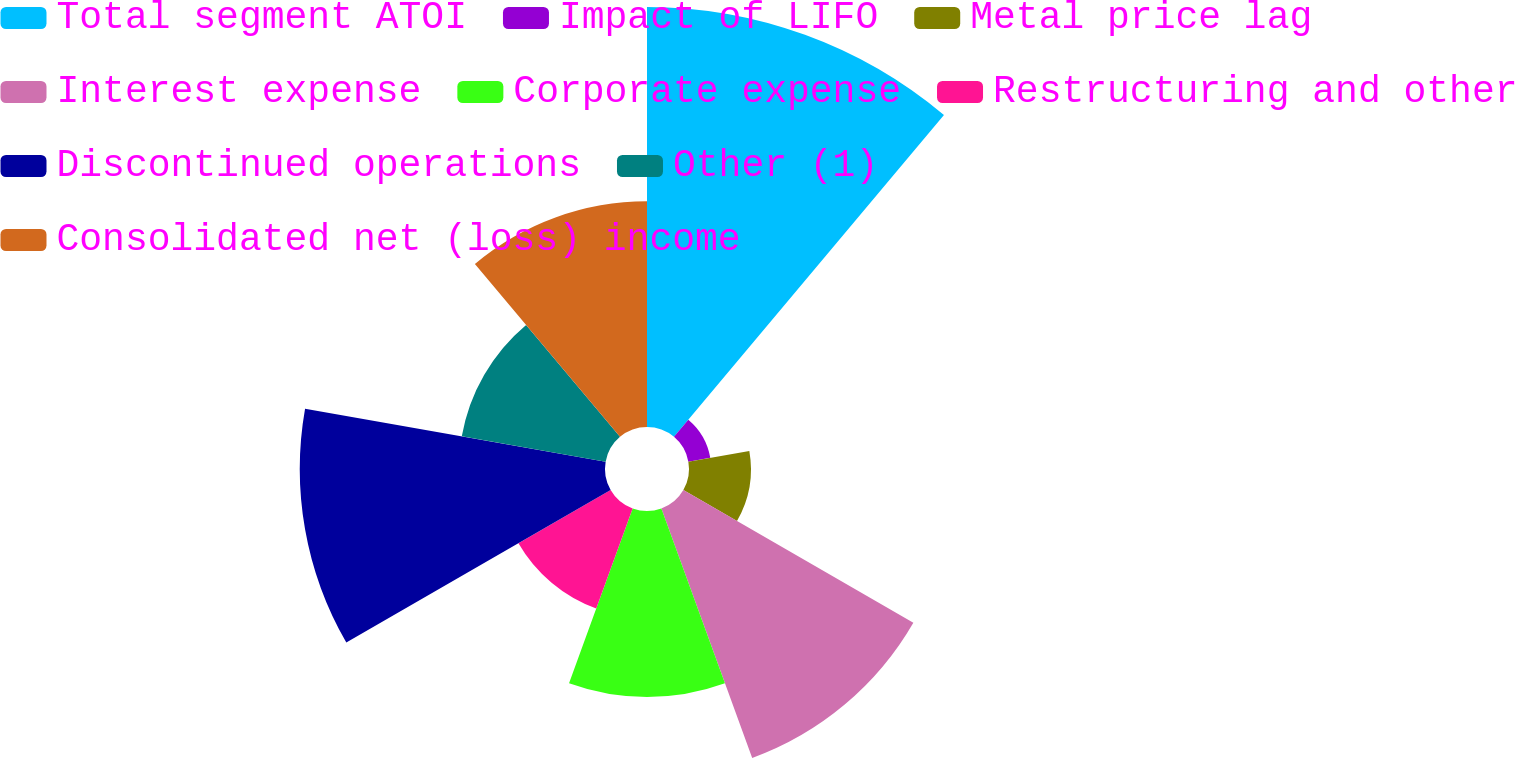<chart> <loc_0><loc_0><loc_500><loc_500><pie_chart><fcel>Total segment ATOI<fcel>Impact of LIFO<fcel>Metal price lag<fcel>Interest expense<fcel>Corporate expense<fcel>Restructuring and other<fcel>Discontinued operations<fcel>Other (1)<fcel>Consolidated net (loss) income<nl><fcel>24.15%<fcel>1.28%<fcel>3.56%<fcel>15.27%<fcel>10.69%<fcel>6.12%<fcel>17.55%<fcel>8.4%<fcel>12.98%<nl></chart> 